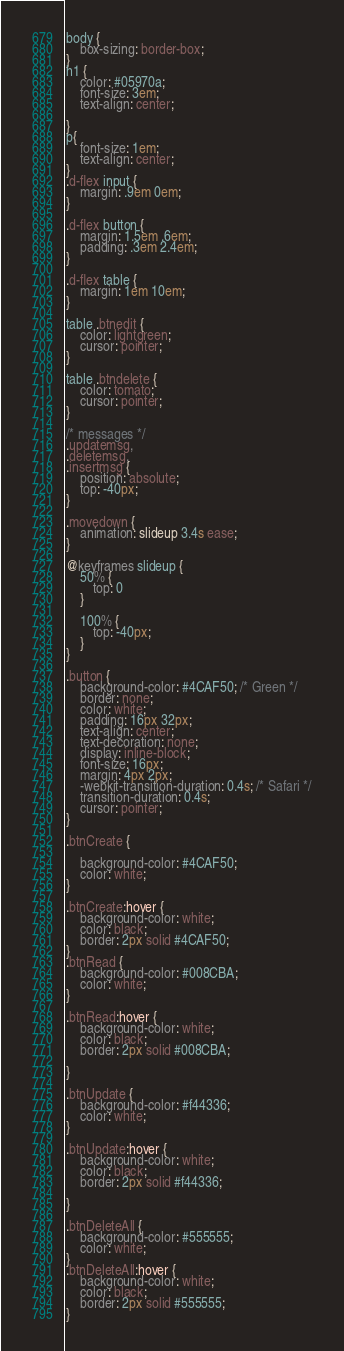Convert code to text. <code><loc_0><loc_0><loc_500><loc_500><_CSS_>body {
    box-sizing: border-box;
}
h1 {
    color: #05970a;
    font-size: 3em; 
    text-align: center;

}
p{
    font-size: 1em;
    text-align: center;
}
.d-flex input {
    margin: .9em 0em;
}

.d-flex button {
    margin: 1.5em .6em;
    padding: .3em 2.4em;
}

.d-flex table {
    margin: 1em 10em;
}

table .btnedit {
    color: lightgreen;
    cursor: pointer;
}

table .btndelete {
    color: tomato;
    cursor: pointer;
}

/* messages */
.updatemsg,
.deletemsg,
.insertmsg {
    position: absolute;
    top: -40px;
}

.movedown {
    animation: slideup 3.4s ease;
}

@keyframes slideup {
    50% {
        top: 0
    }

    100% {
        top: -40px;
    }
}

.button {
    background-color: #4CAF50; /* Green */
    border: none;
    color: white;
    padding: 16px 32px;
    text-align: center;
    text-decoration: none;
    display: inline-block;
    font-size: 16px;
    margin: 4px 2px;
    -webkit-transition-duration: 0.4s; /* Safari */
    transition-duration: 0.4s;
    cursor: pointer;
}

.btnCreate {
   
    background-color: #4CAF50;
    color: white;
}

.btnCreate:hover {
    background-color: white; 
    color: black; 
    border: 2px solid #4CAF50;
}
.btnRead {
    background-color: #008CBA;
    color: white;
}

.btnRead:hover {
    background-color: white; 
    color: black; 
    border: 2px solid #008CBA;

}

.btnUpdate {
    background-color: #f44336;
    color: white;
}

.btnUpdate:hover {
    background-color: white; 
    color: black; 
    border: 2px solid #f44336;
    
}

.btnDeleteAll {
    background-color: #555555;
    color: white;
}
.btnDeleteAll:hover {
    background-color: white;
    color: black;
    border: 2px solid #555555;
}
</code> 